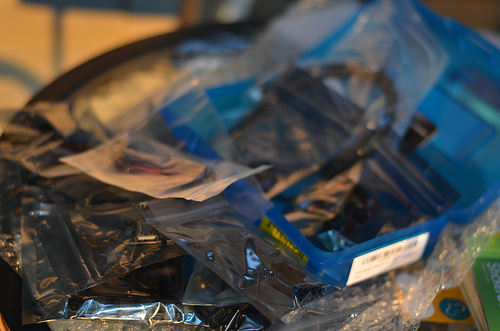<image>
Can you confirm if the baggie is on the wrapper? Yes. Looking at the image, I can see the baggie is positioned on top of the wrapper, with the wrapper providing support. 